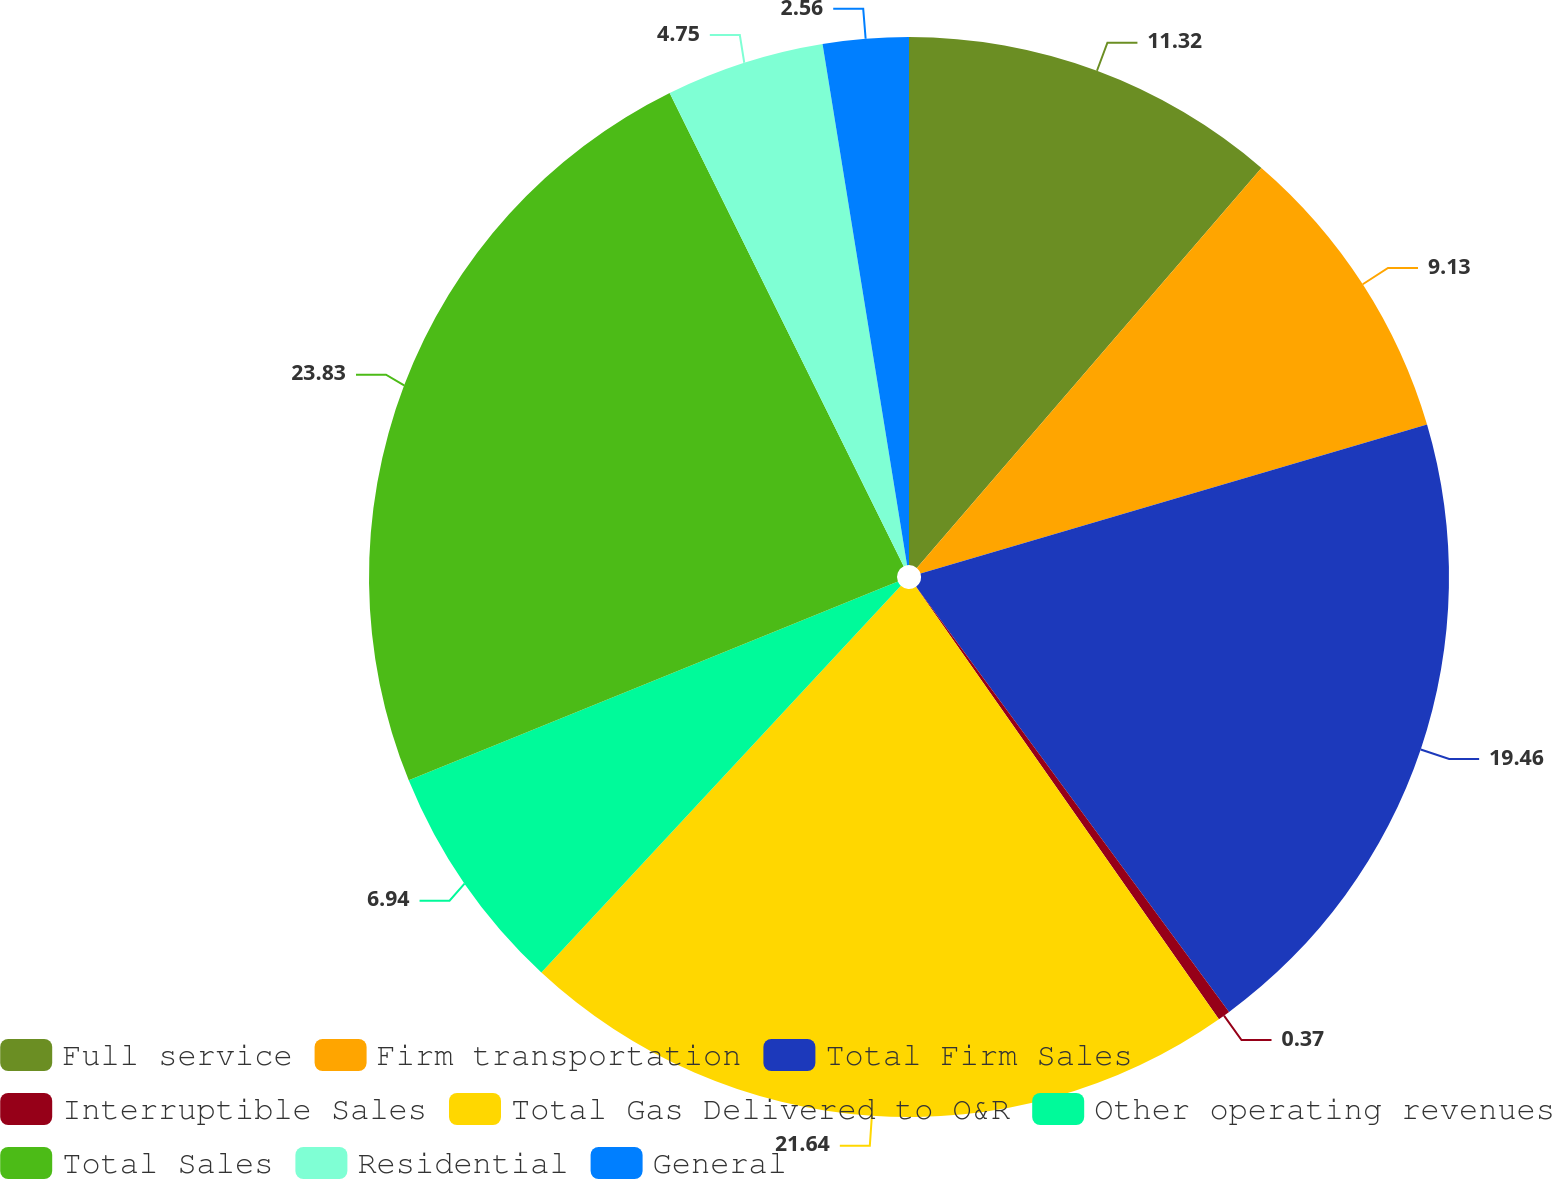Convert chart to OTSL. <chart><loc_0><loc_0><loc_500><loc_500><pie_chart><fcel>Full service<fcel>Firm transportation<fcel>Total Firm Sales<fcel>Interruptible Sales<fcel>Total Gas Delivered to O&R<fcel>Other operating revenues<fcel>Total Sales<fcel>Residential<fcel>General<nl><fcel>11.32%<fcel>9.13%<fcel>19.46%<fcel>0.37%<fcel>21.65%<fcel>6.94%<fcel>23.84%<fcel>4.75%<fcel>2.56%<nl></chart> 